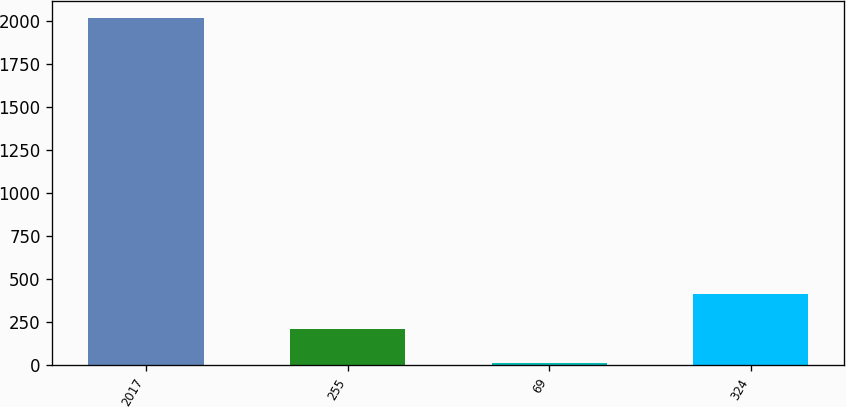Convert chart. <chart><loc_0><loc_0><loc_500><loc_500><bar_chart><fcel>2017<fcel>255<fcel>69<fcel>324<nl><fcel>2015<fcel>209.15<fcel>8.5<fcel>409.8<nl></chart> 